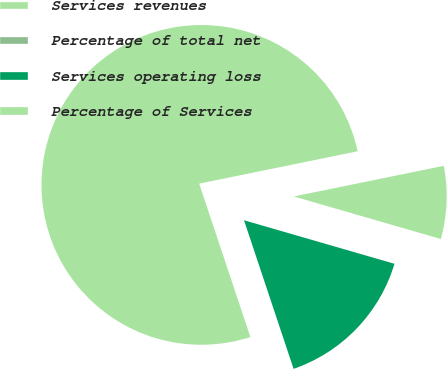Convert chart to OTSL. <chart><loc_0><loc_0><loc_500><loc_500><pie_chart><fcel>Services revenues<fcel>Percentage of total net<fcel>Services operating loss<fcel>Percentage of Services<nl><fcel>76.92%<fcel>0.0%<fcel>15.39%<fcel>7.69%<nl></chart> 